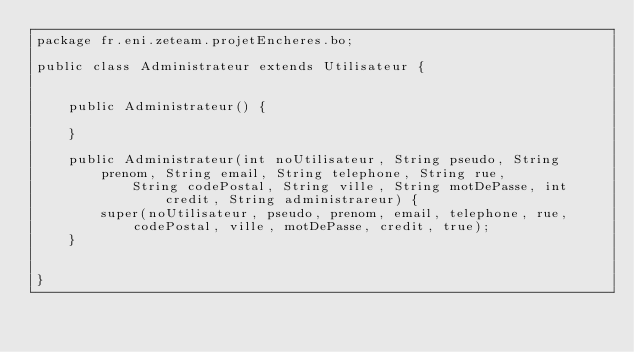Convert code to text. <code><loc_0><loc_0><loc_500><loc_500><_Java_>package fr.eni.zeteam.projetEncheres.bo;

public class Administrateur extends Utilisateur {

	
	public Administrateur() {

	}

	public Administrateur(int noUtilisateur, String pseudo, String prenom, String email, String telephone, String rue,
			String codePostal, String ville, String motDePasse, int credit, String administrareur) {
		super(noUtilisateur, pseudo, prenom, email, telephone, rue, codePostal, ville, motDePasse, credit, true);
	}

	
}
</code> 